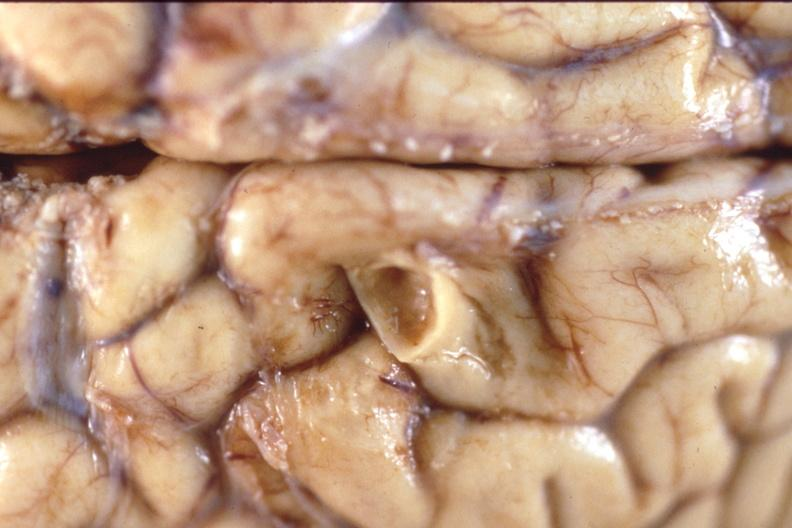what does this image show?
Answer the question using a single word or phrase. Brain 